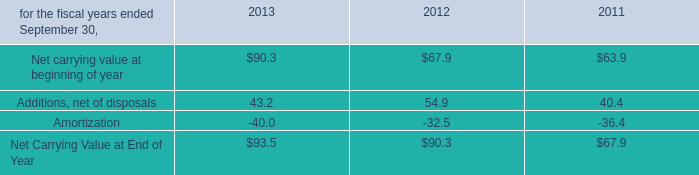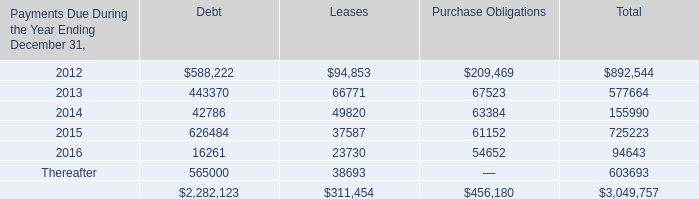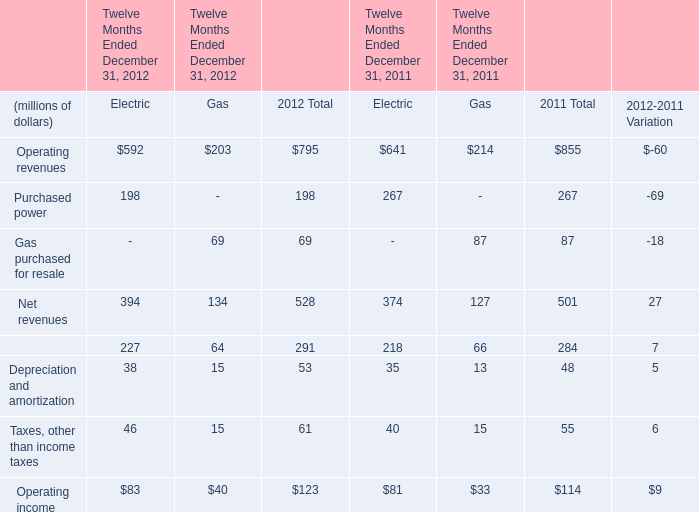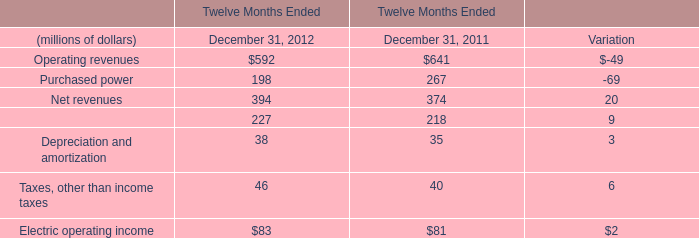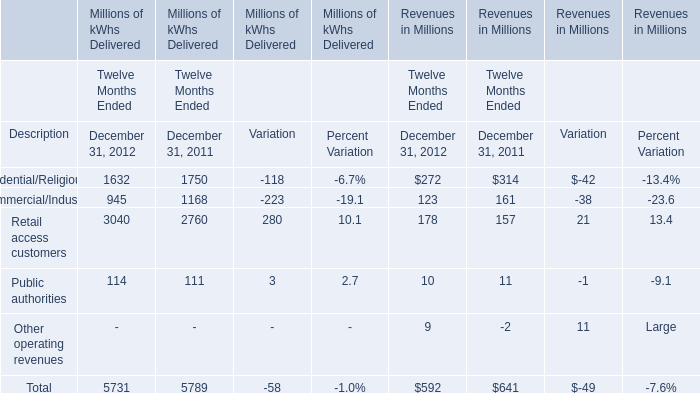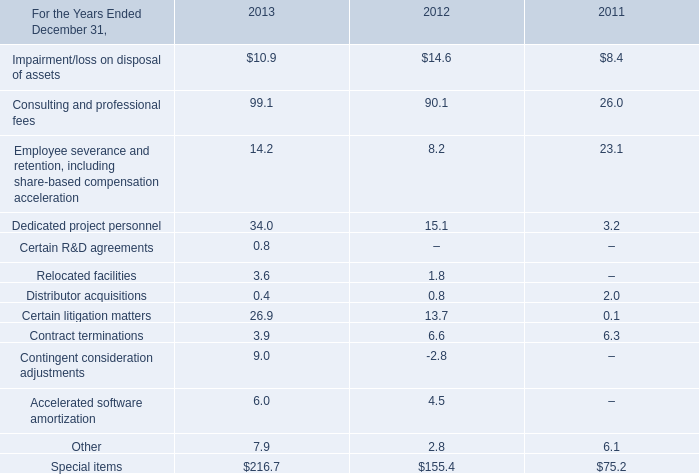In which years is Operating revenues greater than Purchased power? 
Answer: December 31, 2012 December 31, 2011. 